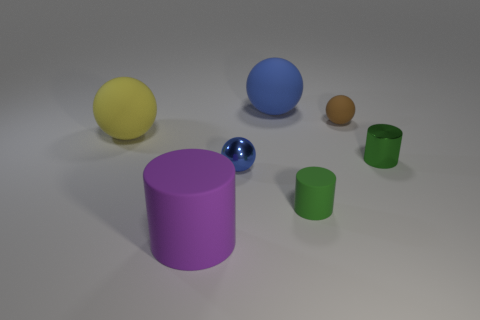Add 3 tiny gray rubber objects. How many objects exist? 10 Subtract all cylinders. How many objects are left? 4 Add 3 blue things. How many blue things are left? 5 Add 4 large purple cylinders. How many large purple cylinders exist? 5 Subtract 0 red balls. How many objects are left? 7 Subtract all tiny brown spheres. Subtract all big cylinders. How many objects are left? 5 